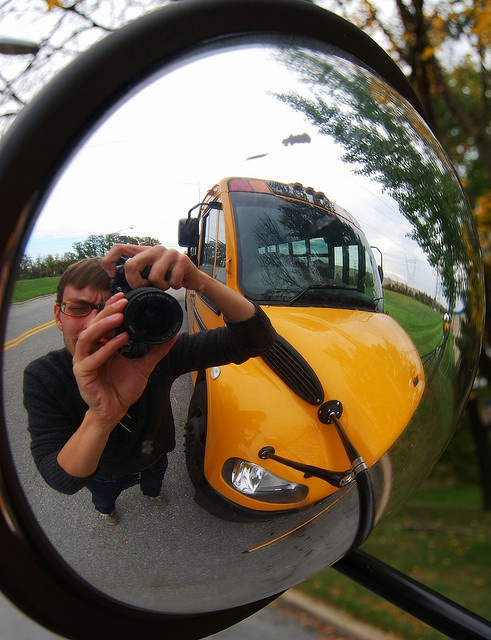Describe the objects in this image and their specific colors. I can see bus in white, black, orange, gray, and red tones and people in white, black, maroon, and brown tones in this image. 